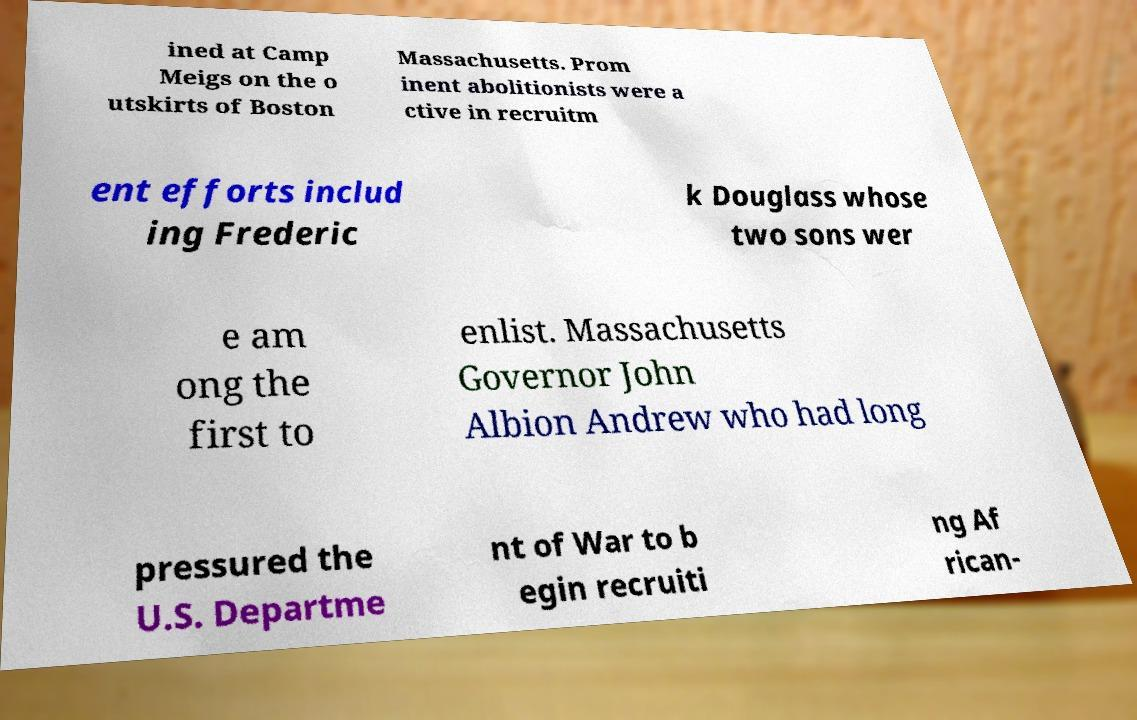Can you read and provide the text displayed in the image?This photo seems to have some interesting text. Can you extract and type it out for me? ined at Camp Meigs on the o utskirts of Boston Massachusetts. Prom inent abolitionists were a ctive in recruitm ent efforts includ ing Frederic k Douglass whose two sons wer e am ong the first to enlist. Massachusetts Governor John Albion Andrew who had long pressured the U.S. Departme nt of War to b egin recruiti ng Af rican- 